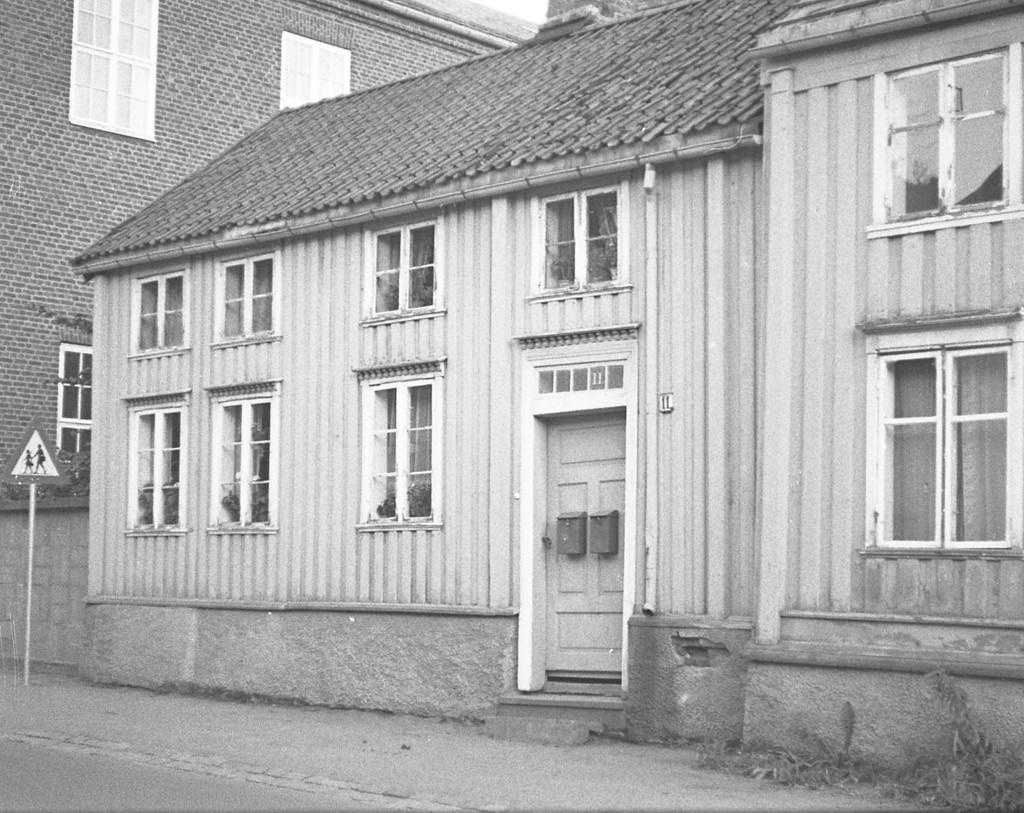What type of structure is visible in the image? There is a house in the image. What features can be seen on the house? The house has windows and a door. What else is present in the image besides the house? There is a signboard in the image. What type of love is depicted on the house in the image? There is no depiction of love on the house in the image; it is simply a house with windows and a door. 